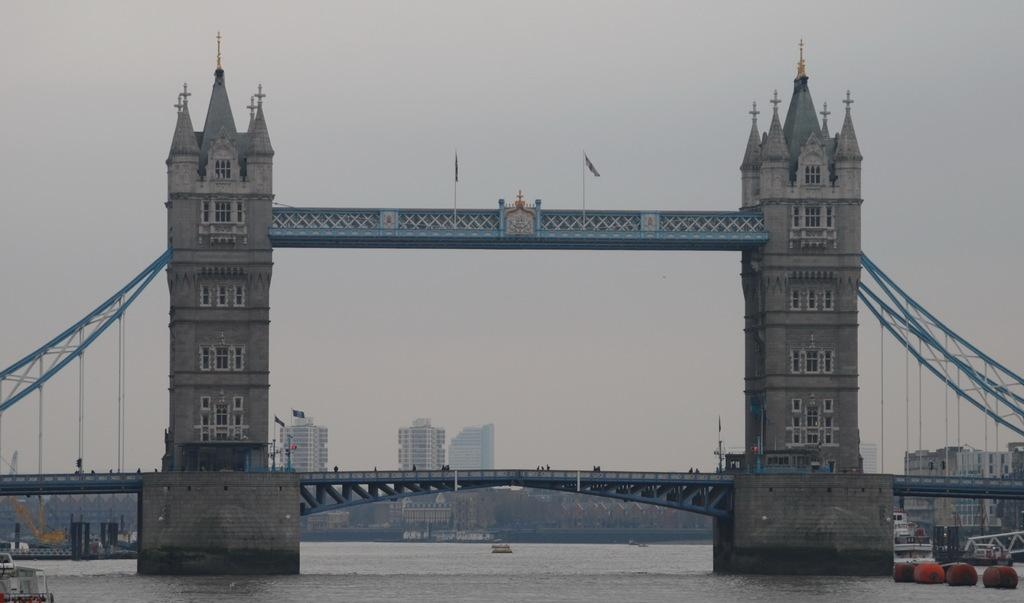What is the primary element in the image? There is water in the image. What structures are built on the water? There are bridges with buildings on the water. What feature can be seen on the buildings? The buildings have windows. What can be seen in the background of the image? There are many buildings and the sky visible in the background of the image. What decorative elements are present on the bridge? There are flags on the bridge. What type of summer activity is taking place in the image? The provided facts do not mention any summer activity taking place in the image. Can you spot a monkey climbing one of the buildings in the image? There is no monkey present in the image. 